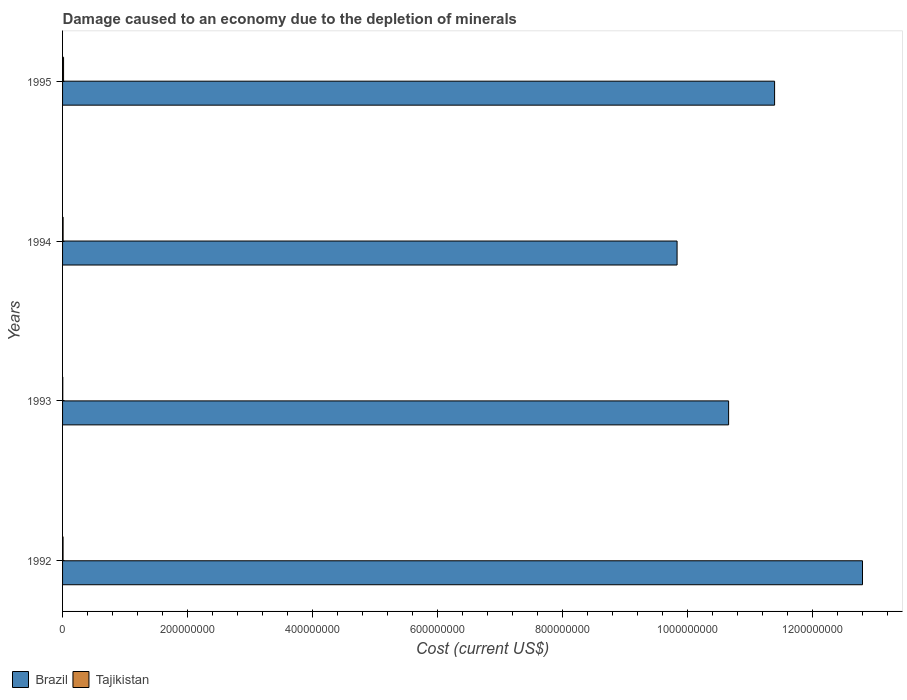How many different coloured bars are there?
Provide a short and direct response. 2. How many groups of bars are there?
Offer a very short reply. 4. What is the cost of damage caused due to the depletion of minerals in Brazil in 1994?
Offer a very short reply. 9.83e+08. Across all years, what is the maximum cost of damage caused due to the depletion of minerals in Brazil?
Your answer should be very brief. 1.28e+09. Across all years, what is the minimum cost of damage caused due to the depletion of minerals in Brazil?
Provide a short and direct response. 9.83e+08. In which year was the cost of damage caused due to the depletion of minerals in Tajikistan maximum?
Your answer should be compact. 1995. In which year was the cost of damage caused due to the depletion of minerals in Brazil minimum?
Your answer should be very brief. 1994. What is the total cost of damage caused due to the depletion of minerals in Tajikistan in the graph?
Offer a very short reply. 3.59e+06. What is the difference between the cost of damage caused due to the depletion of minerals in Tajikistan in 1992 and that in 1994?
Your answer should be very brief. -8.29e+04. What is the difference between the cost of damage caused due to the depletion of minerals in Brazil in 1994 and the cost of damage caused due to the depletion of minerals in Tajikistan in 1993?
Keep it short and to the point. 9.82e+08. What is the average cost of damage caused due to the depletion of minerals in Tajikistan per year?
Offer a terse response. 8.97e+05. In the year 1993, what is the difference between the cost of damage caused due to the depletion of minerals in Brazil and cost of damage caused due to the depletion of minerals in Tajikistan?
Provide a succinct answer. 1.06e+09. In how many years, is the cost of damage caused due to the depletion of minerals in Tajikistan greater than 640000000 US$?
Offer a very short reply. 0. What is the ratio of the cost of damage caused due to the depletion of minerals in Tajikistan in 1993 to that in 1994?
Ensure brevity in your answer.  0.4. Is the difference between the cost of damage caused due to the depletion of minerals in Brazil in 1994 and 1995 greater than the difference between the cost of damage caused due to the depletion of minerals in Tajikistan in 1994 and 1995?
Provide a short and direct response. No. What is the difference between the highest and the second highest cost of damage caused due to the depletion of minerals in Brazil?
Provide a short and direct response. 1.41e+08. What is the difference between the highest and the lowest cost of damage caused due to the depletion of minerals in Tajikistan?
Give a very brief answer. 1.23e+06. In how many years, is the cost of damage caused due to the depletion of minerals in Brazil greater than the average cost of damage caused due to the depletion of minerals in Brazil taken over all years?
Give a very brief answer. 2. What does the 1st bar from the top in 1994 represents?
Provide a succinct answer. Tajikistan. What does the 2nd bar from the bottom in 1994 represents?
Keep it short and to the point. Tajikistan. Are all the bars in the graph horizontal?
Offer a terse response. Yes. What is the difference between two consecutive major ticks on the X-axis?
Your response must be concise. 2.00e+08. Are the values on the major ticks of X-axis written in scientific E-notation?
Your answer should be compact. No. Where does the legend appear in the graph?
Your response must be concise. Bottom left. How many legend labels are there?
Keep it short and to the point. 2. What is the title of the graph?
Offer a very short reply. Damage caused to an economy due to the depletion of minerals. Does "Romania" appear as one of the legend labels in the graph?
Make the answer very short. No. What is the label or title of the X-axis?
Provide a succinct answer. Cost (current US$). What is the label or title of the Y-axis?
Offer a very short reply. Years. What is the Cost (current US$) in Brazil in 1992?
Provide a short and direct response. 1.28e+09. What is the Cost (current US$) in Tajikistan in 1992?
Your answer should be compact. 7.86e+05. What is the Cost (current US$) in Brazil in 1993?
Your answer should be compact. 1.07e+09. What is the Cost (current US$) in Tajikistan in 1993?
Your answer should be compact. 3.49e+05. What is the Cost (current US$) in Brazil in 1994?
Your answer should be very brief. 9.83e+08. What is the Cost (current US$) in Tajikistan in 1994?
Give a very brief answer. 8.69e+05. What is the Cost (current US$) of Brazil in 1995?
Provide a succinct answer. 1.14e+09. What is the Cost (current US$) of Tajikistan in 1995?
Your answer should be very brief. 1.58e+06. Across all years, what is the maximum Cost (current US$) of Brazil?
Give a very brief answer. 1.28e+09. Across all years, what is the maximum Cost (current US$) of Tajikistan?
Offer a terse response. 1.58e+06. Across all years, what is the minimum Cost (current US$) in Brazil?
Make the answer very short. 9.83e+08. Across all years, what is the minimum Cost (current US$) of Tajikistan?
Offer a very short reply. 3.49e+05. What is the total Cost (current US$) in Brazil in the graph?
Give a very brief answer. 4.47e+09. What is the total Cost (current US$) in Tajikistan in the graph?
Keep it short and to the point. 3.59e+06. What is the difference between the Cost (current US$) of Brazil in 1992 and that in 1993?
Make the answer very short. 2.14e+08. What is the difference between the Cost (current US$) in Tajikistan in 1992 and that in 1993?
Make the answer very short. 4.37e+05. What is the difference between the Cost (current US$) in Brazil in 1992 and that in 1994?
Keep it short and to the point. 2.97e+08. What is the difference between the Cost (current US$) of Tajikistan in 1992 and that in 1994?
Ensure brevity in your answer.  -8.29e+04. What is the difference between the Cost (current US$) of Brazil in 1992 and that in 1995?
Your answer should be compact. 1.41e+08. What is the difference between the Cost (current US$) of Tajikistan in 1992 and that in 1995?
Make the answer very short. -7.97e+05. What is the difference between the Cost (current US$) in Brazil in 1993 and that in 1994?
Your answer should be very brief. 8.24e+07. What is the difference between the Cost (current US$) in Tajikistan in 1993 and that in 1994?
Keep it short and to the point. -5.20e+05. What is the difference between the Cost (current US$) in Brazil in 1993 and that in 1995?
Your response must be concise. -7.35e+07. What is the difference between the Cost (current US$) in Tajikistan in 1993 and that in 1995?
Provide a succinct answer. -1.23e+06. What is the difference between the Cost (current US$) in Brazil in 1994 and that in 1995?
Ensure brevity in your answer.  -1.56e+08. What is the difference between the Cost (current US$) in Tajikistan in 1994 and that in 1995?
Offer a terse response. -7.14e+05. What is the difference between the Cost (current US$) of Brazil in 1992 and the Cost (current US$) of Tajikistan in 1993?
Ensure brevity in your answer.  1.28e+09. What is the difference between the Cost (current US$) in Brazil in 1992 and the Cost (current US$) in Tajikistan in 1994?
Make the answer very short. 1.28e+09. What is the difference between the Cost (current US$) in Brazil in 1992 and the Cost (current US$) in Tajikistan in 1995?
Keep it short and to the point. 1.28e+09. What is the difference between the Cost (current US$) in Brazil in 1993 and the Cost (current US$) in Tajikistan in 1994?
Give a very brief answer. 1.06e+09. What is the difference between the Cost (current US$) in Brazil in 1993 and the Cost (current US$) in Tajikistan in 1995?
Make the answer very short. 1.06e+09. What is the difference between the Cost (current US$) of Brazil in 1994 and the Cost (current US$) of Tajikistan in 1995?
Make the answer very short. 9.81e+08. What is the average Cost (current US$) in Brazil per year?
Give a very brief answer. 1.12e+09. What is the average Cost (current US$) of Tajikistan per year?
Provide a short and direct response. 8.97e+05. In the year 1992, what is the difference between the Cost (current US$) of Brazil and Cost (current US$) of Tajikistan?
Your answer should be compact. 1.28e+09. In the year 1993, what is the difference between the Cost (current US$) in Brazil and Cost (current US$) in Tajikistan?
Your answer should be compact. 1.06e+09. In the year 1994, what is the difference between the Cost (current US$) in Brazil and Cost (current US$) in Tajikistan?
Provide a succinct answer. 9.82e+08. In the year 1995, what is the difference between the Cost (current US$) in Brazil and Cost (current US$) in Tajikistan?
Ensure brevity in your answer.  1.14e+09. What is the ratio of the Cost (current US$) in Brazil in 1992 to that in 1993?
Your response must be concise. 1.2. What is the ratio of the Cost (current US$) of Tajikistan in 1992 to that in 1993?
Offer a very short reply. 2.25. What is the ratio of the Cost (current US$) of Brazil in 1992 to that in 1994?
Give a very brief answer. 1.3. What is the ratio of the Cost (current US$) of Tajikistan in 1992 to that in 1994?
Your answer should be compact. 0.9. What is the ratio of the Cost (current US$) in Brazil in 1992 to that in 1995?
Your response must be concise. 1.12. What is the ratio of the Cost (current US$) in Tajikistan in 1992 to that in 1995?
Your response must be concise. 0.5. What is the ratio of the Cost (current US$) in Brazil in 1993 to that in 1994?
Keep it short and to the point. 1.08. What is the ratio of the Cost (current US$) in Tajikistan in 1993 to that in 1994?
Offer a terse response. 0.4. What is the ratio of the Cost (current US$) of Brazil in 1993 to that in 1995?
Provide a short and direct response. 0.94. What is the ratio of the Cost (current US$) of Tajikistan in 1993 to that in 1995?
Offer a very short reply. 0.22. What is the ratio of the Cost (current US$) of Brazil in 1994 to that in 1995?
Offer a very short reply. 0.86. What is the ratio of the Cost (current US$) in Tajikistan in 1994 to that in 1995?
Offer a terse response. 0.55. What is the difference between the highest and the second highest Cost (current US$) of Brazil?
Offer a terse response. 1.41e+08. What is the difference between the highest and the second highest Cost (current US$) in Tajikistan?
Provide a short and direct response. 7.14e+05. What is the difference between the highest and the lowest Cost (current US$) in Brazil?
Offer a terse response. 2.97e+08. What is the difference between the highest and the lowest Cost (current US$) of Tajikistan?
Offer a very short reply. 1.23e+06. 